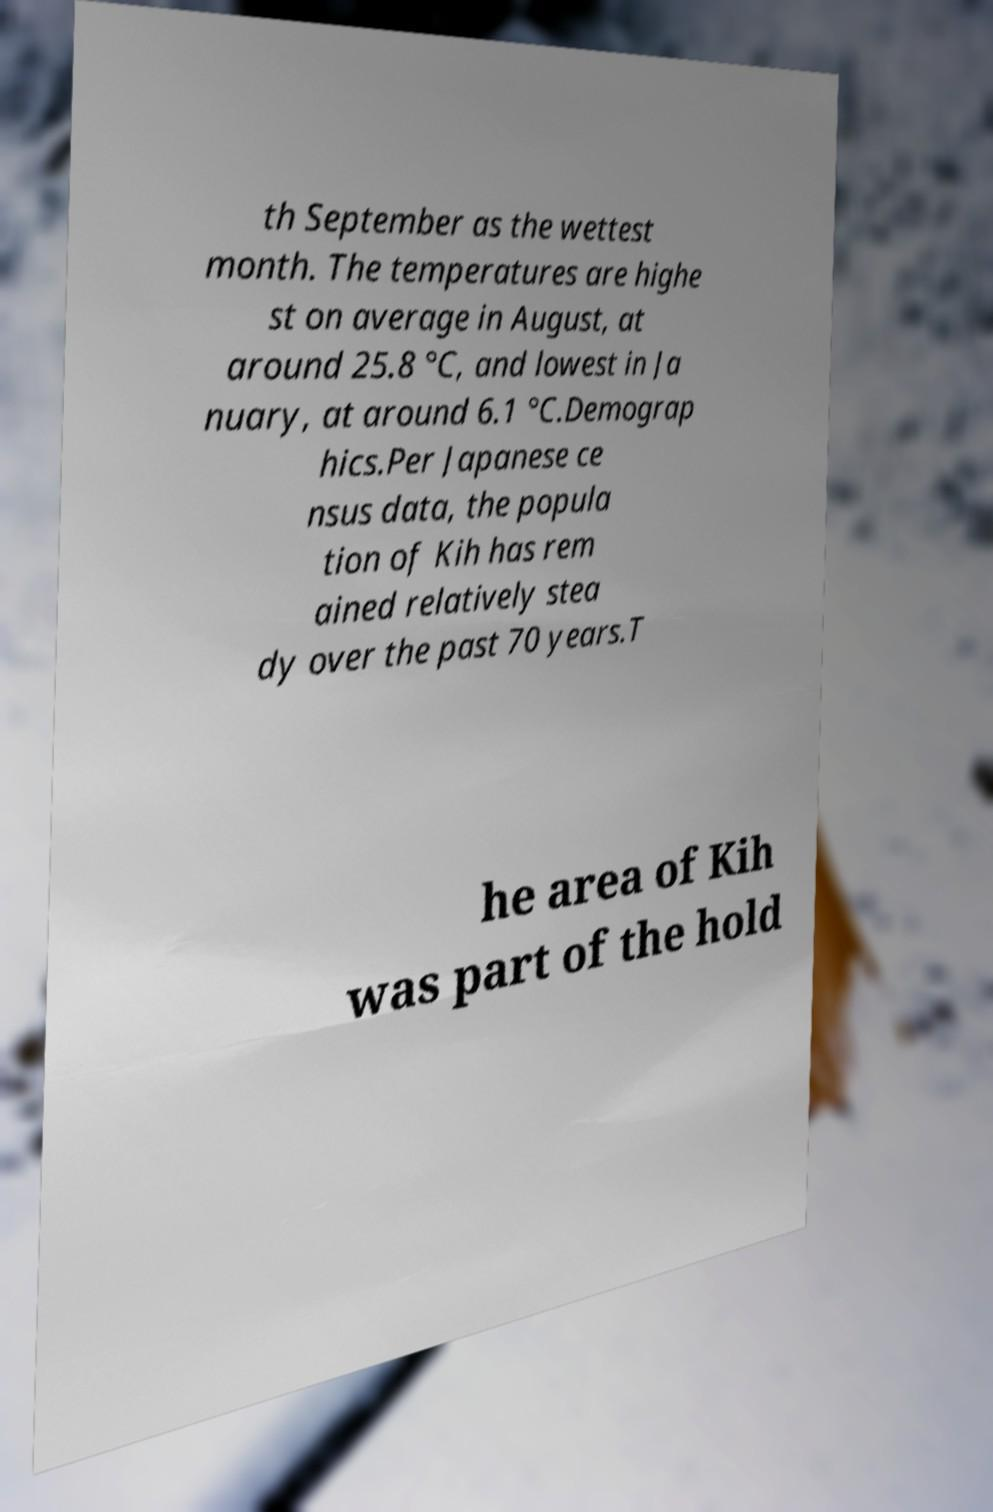There's text embedded in this image that I need extracted. Can you transcribe it verbatim? th September as the wettest month. The temperatures are highe st on average in August, at around 25.8 °C, and lowest in Ja nuary, at around 6.1 °C.Demograp hics.Per Japanese ce nsus data, the popula tion of Kih has rem ained relatively stea dy over the past 70 years.T he area of Kih was part of the hold 